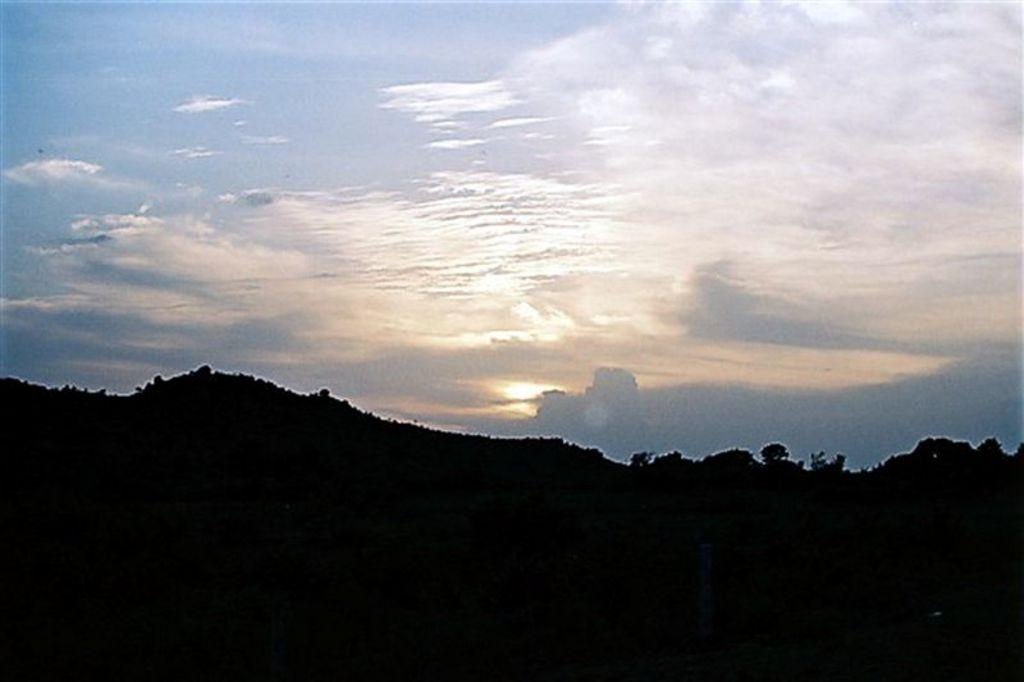What type of landscape can be seen in the background of the image? There are hills in the background of the image. Are there any plants or vegetation on the hills? Yes, the hills have trees on them. What is visible in the sky in the image? The sky is visible in the image, and clouds are present. What type of apparel is being worn by the wax figure in the image? There is no wax figure or apparel present in the image; it features hills with trees and a sky with clouds. 